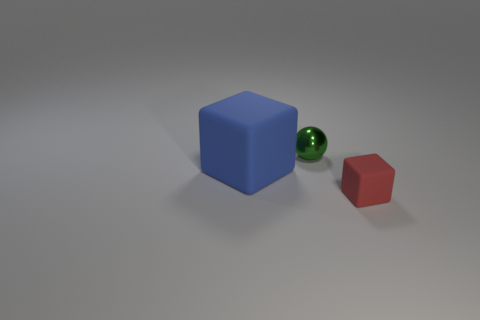Add 2 large rubber things. How many objects exist? 5 Subtract all blocks. How many objects are left? 1 Add 2 red things. How many red things are left? 3 Add 2 small spheres. How many small spheres exist? 3 Subtract 0 gray blocks. How many objects are left? 3 Subtract all tiny red cylinders. Subtract all red rubber cubes. How many objects are left? 2 